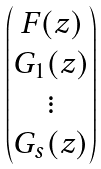Convert formula to latex. <formula><loc_0><loc_0><loc_500><loc_500>\begin{pmatrix} F ( z ) \\ G _ { 1 } ( z ) \\ \vdots \\ G _ { s } ( z ) \end{pmatrix}</formula> 